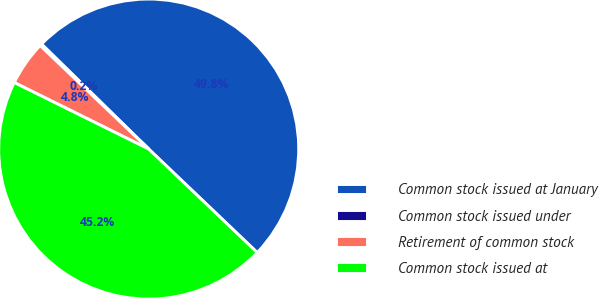Convert chart to OTSL. <chart><loc_0><loc_0><loc_500><loc_500><pie_chart><fcel>Common stock issued at January<fcel>Common stock issued under<fcel>Retirement of common stock<fcel>Common stock issued at<nl><fcel>49.79%<fcel>0.21%<fcel>4.81%<fcel>45.19%<nl></chart> 